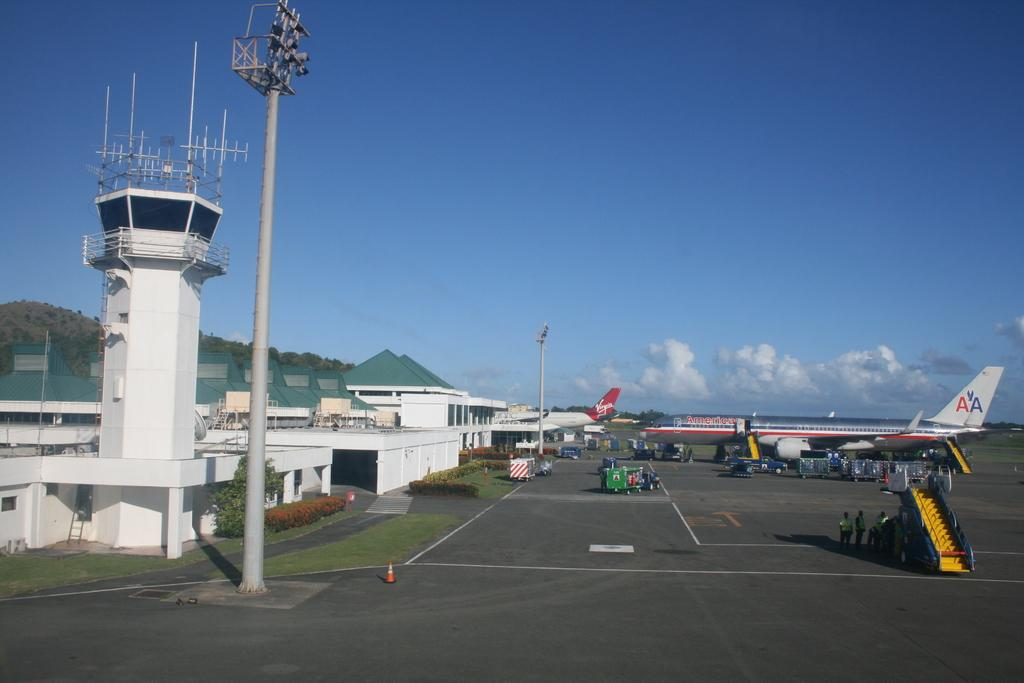<image>
Write a terse but informative summary of the picture. A plane displaying the American Airlines logo of AA sits at an airport next to a runway. 